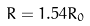<formula> <loc_0><loc_0><loc_500><loc_500>R = 1 . 5 4 R _ { 0 }</formula> 